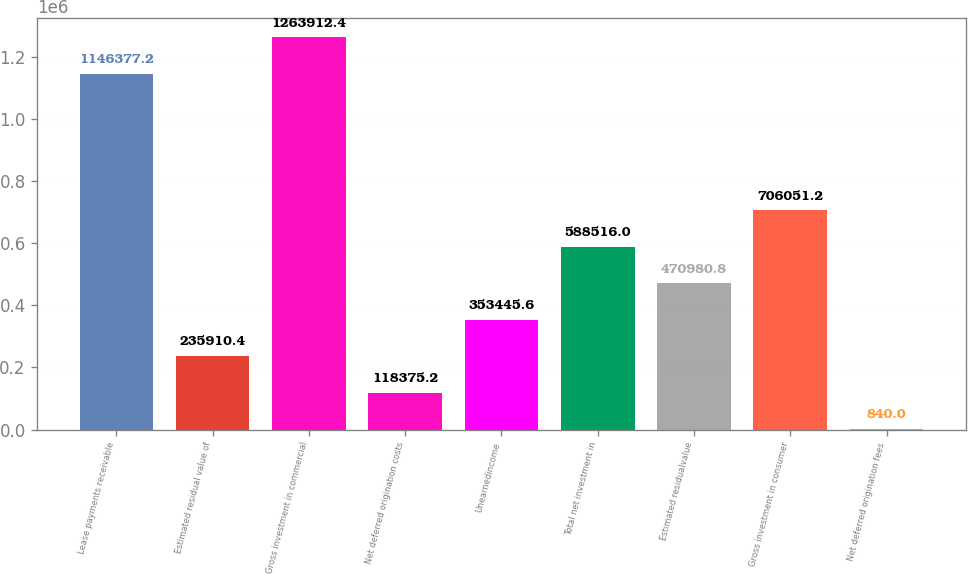Convert chart. <chart><loc_0><loc_0><loc_500><loc_500><bar_chart><fcel>Lease payments receivable<fcel>Estimated residual value of<fcel>Gross investment in commercial<fcel>Net deferred origination costs<fcel>Unearnedincome<fcel>Total net investment in<fcel>Estimated residualvalue<fcel>Gross investment in consumer<fcel>Net deferred origination fees<nl><fcel>1.14638e+06<fcel>235910<fcel>1.26391e+06<fcel>118375<fcel>353446<fcel>588516<fcel>470981<fcel>706051<fcel>840<nl></chart> 